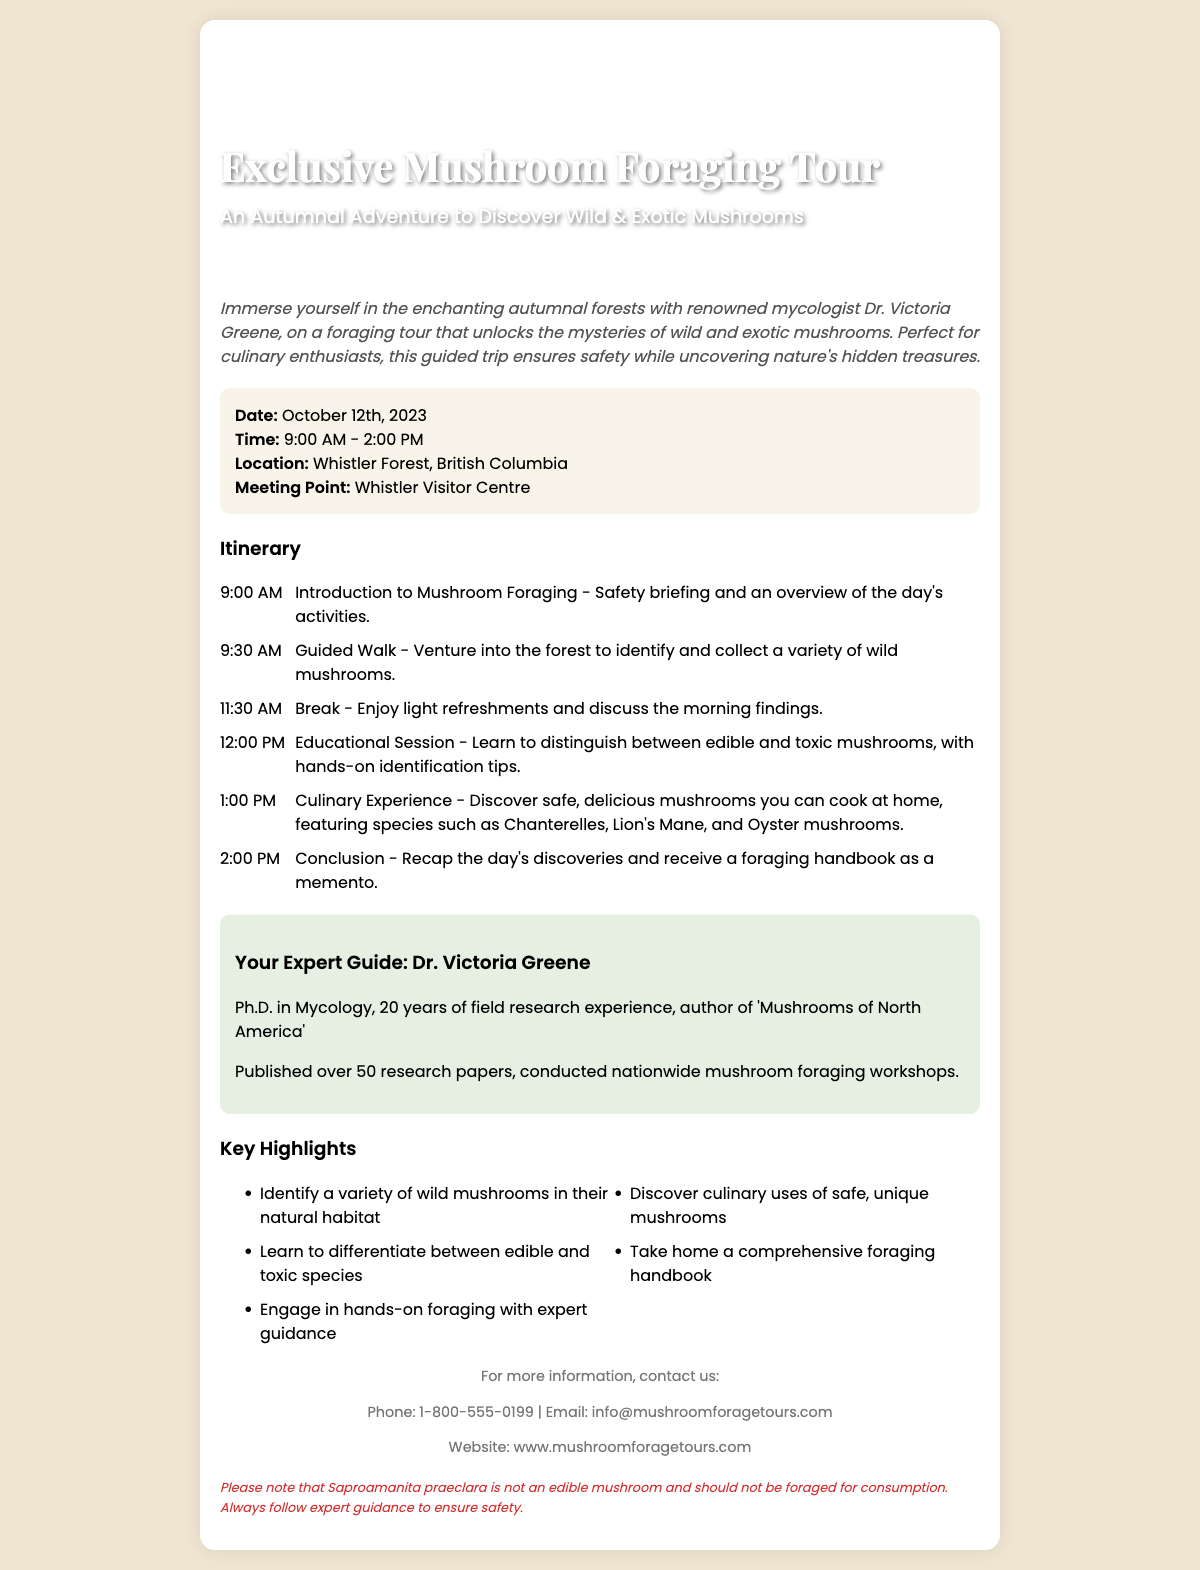What is the name of the expert guiding the foraging tour? The document provides the name of the expert, Dr. Victoria Greene, who will lead the tour.
Answer: Dr. Victoria Greene What is the location of the foraging tour? The document specifies that the tour will take place in Whistler Forest, British Columbia.
Answer: Whistler Forest, British Columbia What date is the mushroom foraging tour scheduled? The document states the specific date of the event as October 12th, 2023.
Answer: October 12th, 2023 What time does the foraging tour begin? The starting time for the tour is mentioned in the itinerary section of the document.
Answer: 9:00 AM What is one of the safe mushrooms that participants will learn about? The document lists specific mushrooms that are safe for culinary use, including Chanterelles.
Answer: Chanterelles What should participants take home as a memento from the tour? The document indicates that attendees will receive a foraging handbook at the end of the tour.
Answer: Foraging handbook Why is Saproamanita praeclara mentioned in the document? The document mentions the mushroom to clarify that it is not edible and should not be foraged.
Answer: Not an edible mushroom What key component is included in the itinerary between 11:30 AM and 12:00 PM? The document details an activity during this timeframe that involves discussing findings and refreshments.
Answer: Break How long is the total duration of the foraging tour? The document outlines the tour's starting and ending times, indicating its total duration.
Answer: 5 hours 